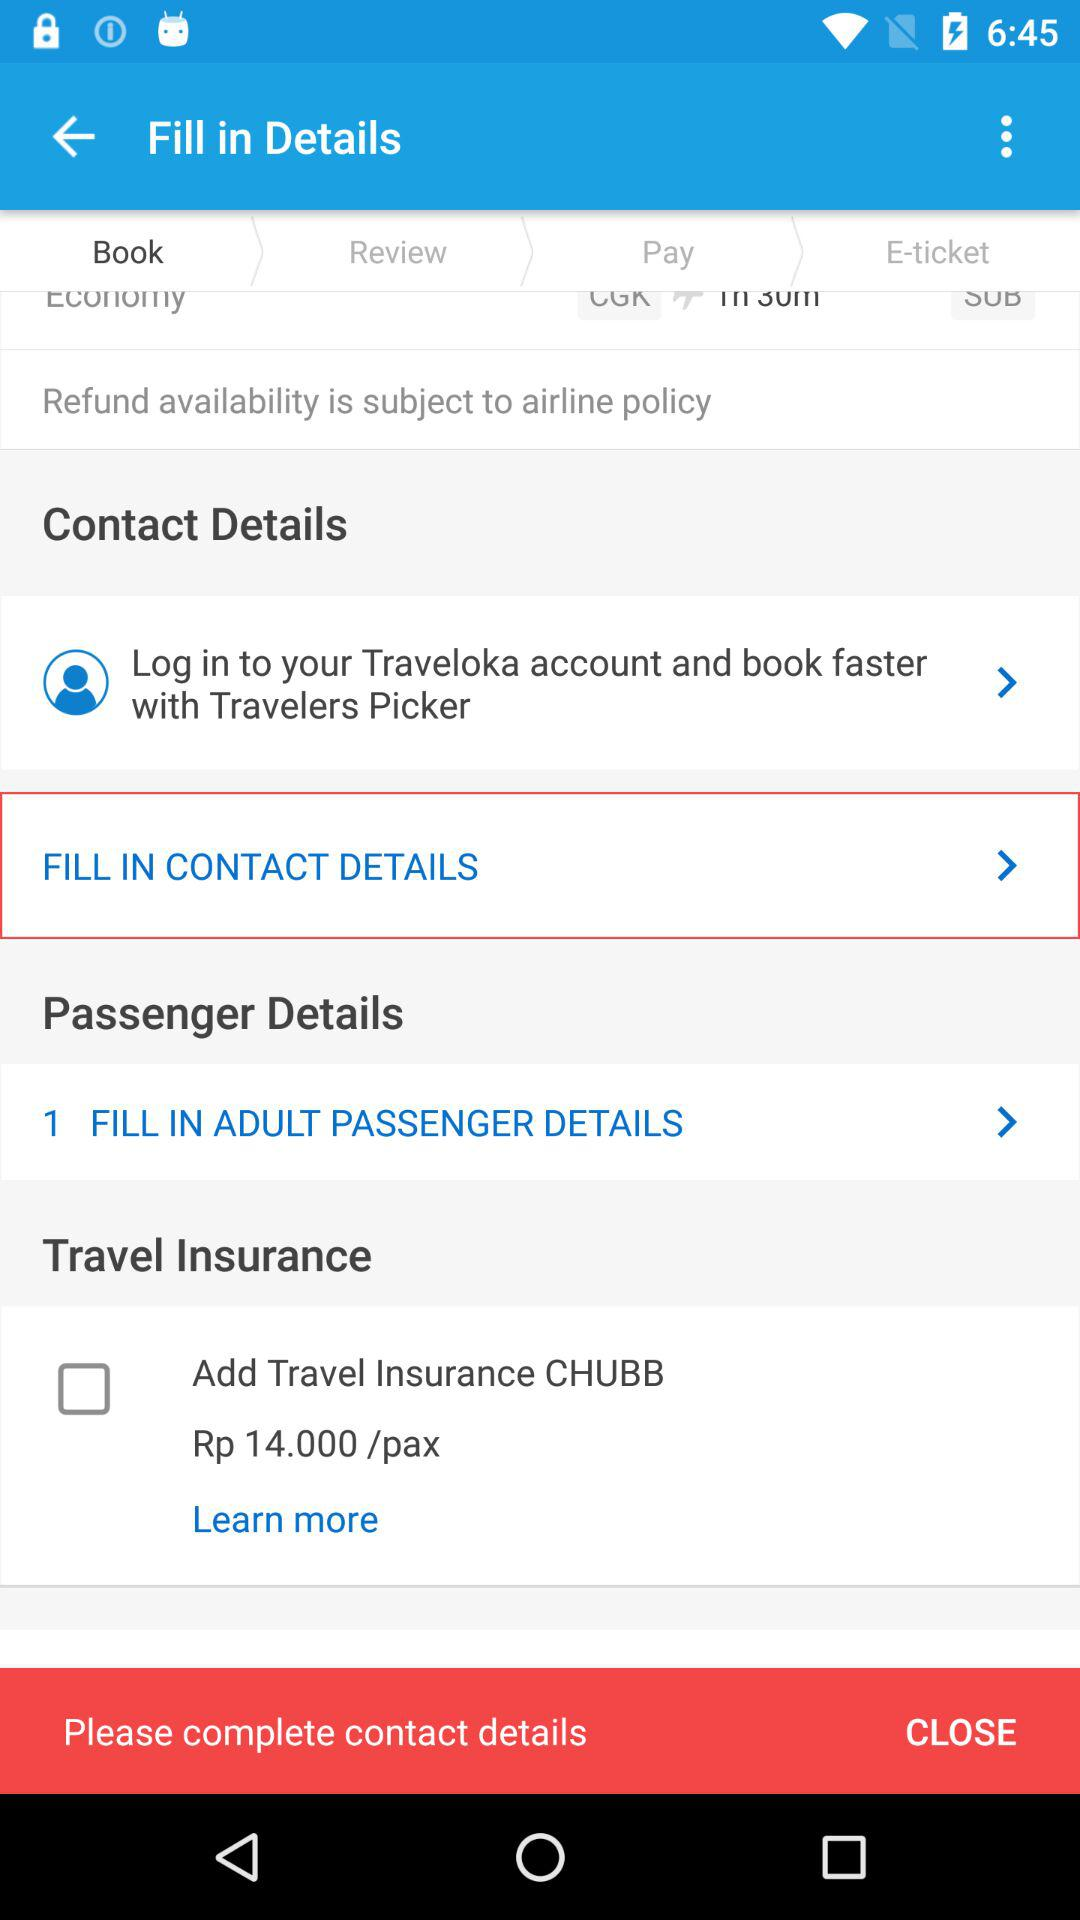What is the status of "Add Travel Insurance CHUBB"? The status is "off". 